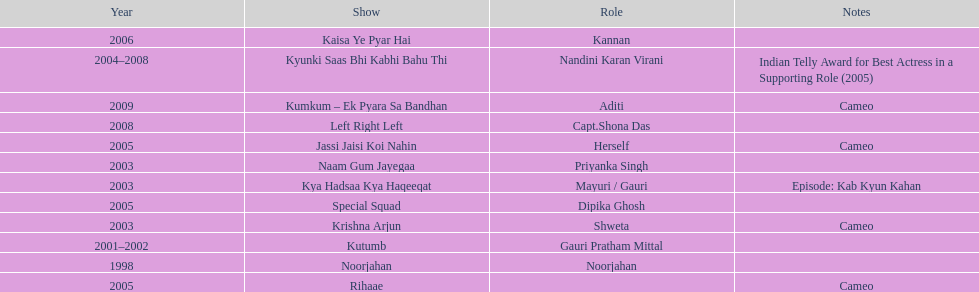How many shows were there in 2005? 3. 